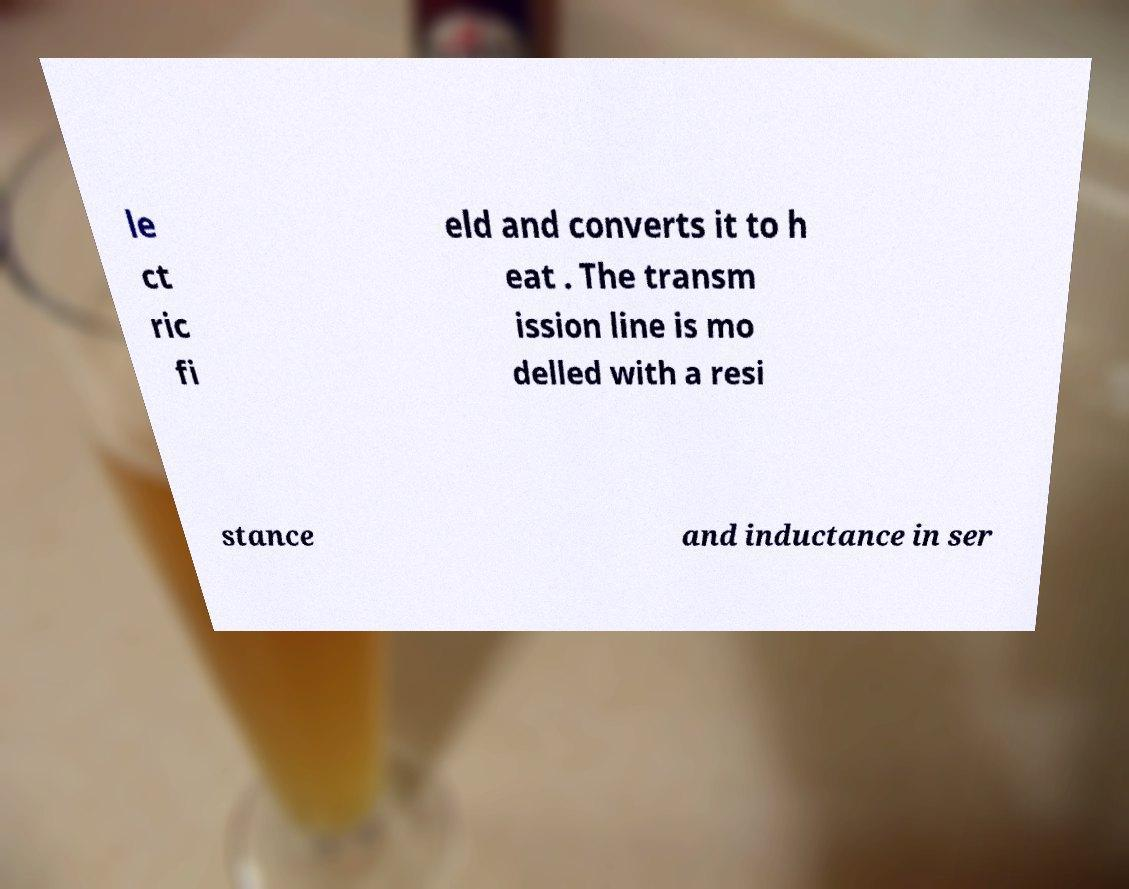Please identify and transcribe the text found in this image. le ct ric fi eld and converts it to h eat . The transm ission line is mo delled with a resi stance and inductance in ser 